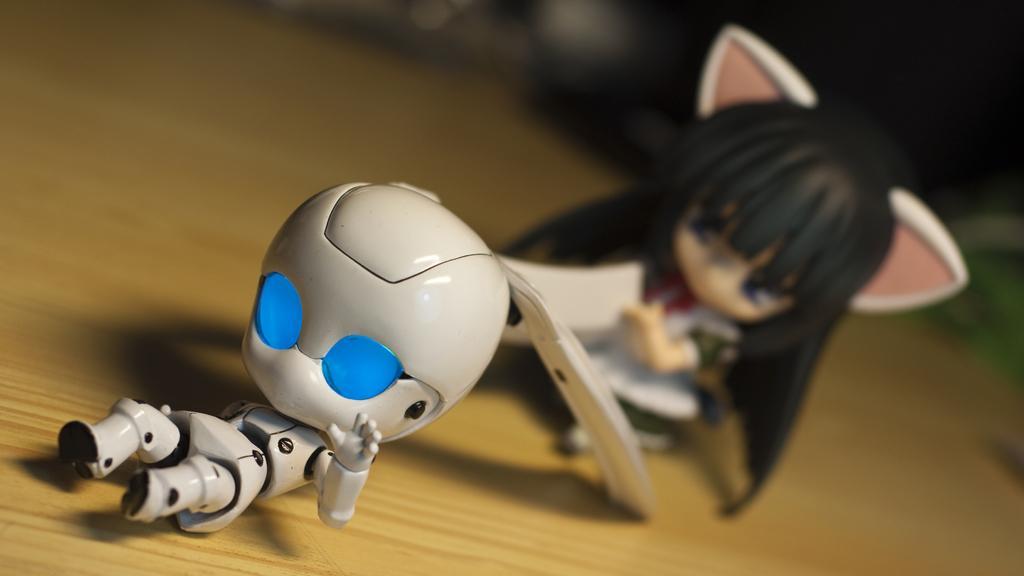In one or two sentences, can you explain what this image depicts? In this image there are toys on a wooden table. 